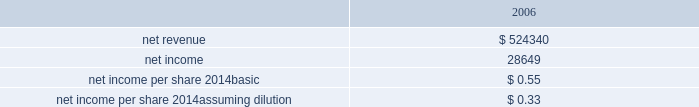Hologic , inc .
Notes to consolidated financial statements ( continued ) ( in thousands , except per share data ) the company has considered the provision of eitf issue no .
95-8 , accounting for contingent consideration paid to the shareholders of and acquired enterprise in a purchase business combination , and concluded that this contingent consideration represents additional purchase price .
During the fourth quarter of fiscal 2007 the company paid approximately $ 19000 to former suros shareholders for the first annual earn-out period resulting in an increase to goodwill for the same amount .
Goodwill will be increased by the amount of the additional consideration , if any , when it becomes due and payable for the second annual earn-out .
In addition to the earn-out discussed above , the company increased goodwill related to the suros acquisition in the amount of $ 210 during the year ended september 29 , 2007 .
The increase was primarily related to recording a liability of approximately $ 550 in accordance with eitf 95-3 related to the termination of certain employees who have ceased all services for the company .
Approximately $ 400 of this liability was paid during the year ended september 29 , 2007 and the balance is expected to be paid by the end of the second quarter of fiscal 2008 .
This increase was partially offset by a decrease to goodwill as a result of a change in the valuation of certain assets and liabilities acquired based on information received during the year ended september 29 , 2007 .
There have been no other material changes to purchase price allocations as disclosed in the company 2019s form 10-k for the year ended september 30 , 2006 .
As part of the purchase price allocation , all intangible assets that were a part of the acquisition were identified and valued .
It was determined that only customer relationship , trade name , developed technology and know how and in-process research and development had separately identifiable values .
Customer relationship represents suros large installed base that are expected to purchase disposable products on a regular basis .
Trade name represent the suros product names that the company intends to continue to use .
Developed technology and know how represents currently marketable purchased products that the company continues to resell as well as utilize to enhance and incorporate into the company 2019s existing products .
The estimated $ 4900 of purchase price allocated to in-process research and development projects primarily related to suros 2019 disposable products .
The projects were at various stages of completion and include next generation handpiece and site marker technologies .
The company has continued to work on these projects and expects they will be completed during fiscal 2008 .
The deferred income tax liability relates to the tax effect of acquired identifiable intangible assets , and fair value adjustments to acquired inventory as such amounts are not deductible for tax purposes , partially offset by acquired net operating loss carry forwards that the company believes are realizable .
For all of the acquisitions discussed above , goodwill represents the excess of the purchase price over the net identifiable tangible and intangible assets acquired .
The company determined that the acquisition of each aeg , biolucent , r2 and suros resulted in the recognition of goodwill primarily because of synergies unique to the company and the strength of its acquired workforce .
Supplemental unaudited pro-forma information the following unaudited pro forma information presents the consolidated results of operations of the company , r2 and suros as if the acquisitions had occurred at the beginning of fiscal 2006 , with pro forma adjustments to give effect to amortization of intangible assets , an increase in interest expense on acquisition financing and certain other adjustments together with related tax effects: .

Based on the eps , how many shares are estimated to be oustanding? 
Computations: (28649 / 0.55)
Answer: 52089.09091. 